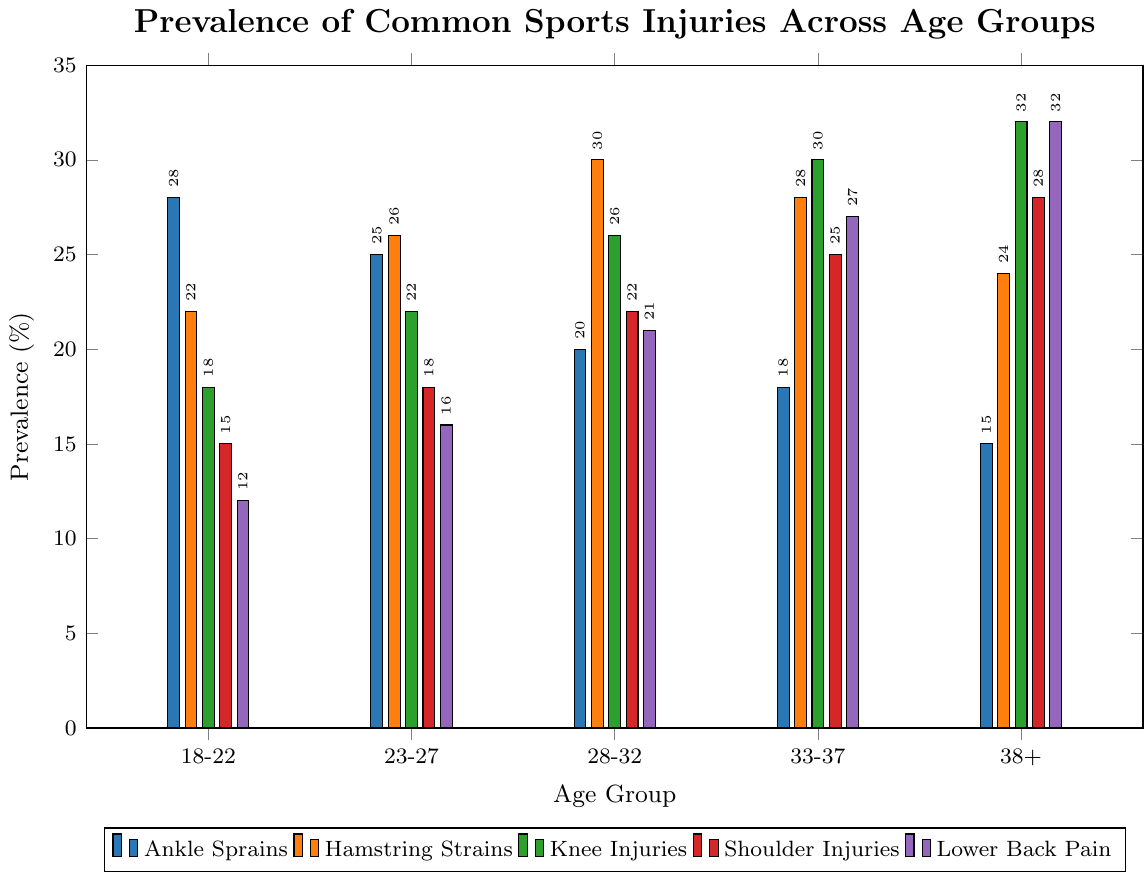Which age group has the highest prevalence of hamstring strains? First, visually identify which bar represents hamstring strains. It is the second color from the left in the legend. Then, compare the height of the bars across all age groups. The highest bar for hamstring strains is in the 28-32 age group.
Answer: 28-32 What is the difference in prevalence between knee injuries in the 33-37 age group and the 18-22 age group? Identify the bars representing knee injuries, which is the third color in the legend. Find the values for the 33-37 age group (30%) and the 18-22 age group (18%). Subtract the smaller value from the larger one: 30 - 18.
Answer: 12% Which injury type has the highest increase in prevalence from the 18-22 group to the 38+ group? For each injury type, find the difference in prevalence between the 38+ group and the 18-22 group. The differences are: Ankle Sprains: 15 - 28 = -13, Hamstring Strains: 24 - 22 = 2, Knee Injuries: 32 - 18 = 14, Shoulder Injuries: 28 - 15 = 13, Lower Back Pain: 32 - 12 = 20. The highest increase in prevalence occurs in Lower Back Pain.
Answer: Lower Back Pain Among the age groups 18-22 and 23-27, which group has a higher total prevalence of all injuries combined? Sum the prevalences for each injury within the 18-22 age group (28+22+18+15+12=95). Do the same for the 23-27 age group (25+26+22+18+16=107). Compare the totals. The 23-27 age group has a higher total prevalence.
Answer: 23-27 Which age group has the lowest combined prevalence of ankle sprains and shoulder injuries? For each age group, sum the prevalences of ankle sprains and shoulder injuries. The values are: 18-22: 28+15=43, 23-27: 25+18=43, 28-32: 20+22=42, 33-37: 18+25=43, 38+: 15+28=43. The 28-32 age group has the lowest combined prevalence.
Answer: 28-32 What is the average prevalence of lower back pain across all age groups? Add the prevalence values for lower back pain across all age groups (12+16+21+27+32=108). Then, divide the total by the number of age groups (5). 108 / 5.
Answer: 21.6% Compare the prevalence of knee injuries for the 28-32 and 33-37 age groups. Which group has a higher prevalence, and by how much? Identify the prevalence of knee injuries for both age groups: 28-32 (26%) and 33-37 (30%). The difference is 30 - 26. Thus, the 33-37 age group has a higher prevalence by 4%.
Answer: 33-37 by 4% What is the most common injury type in the 38+ age group? Visually identify the tallest bar for the 38+ age group. This corresponds to knee injuries with a prevalence of 32%.
Answer: Knee Injuries 